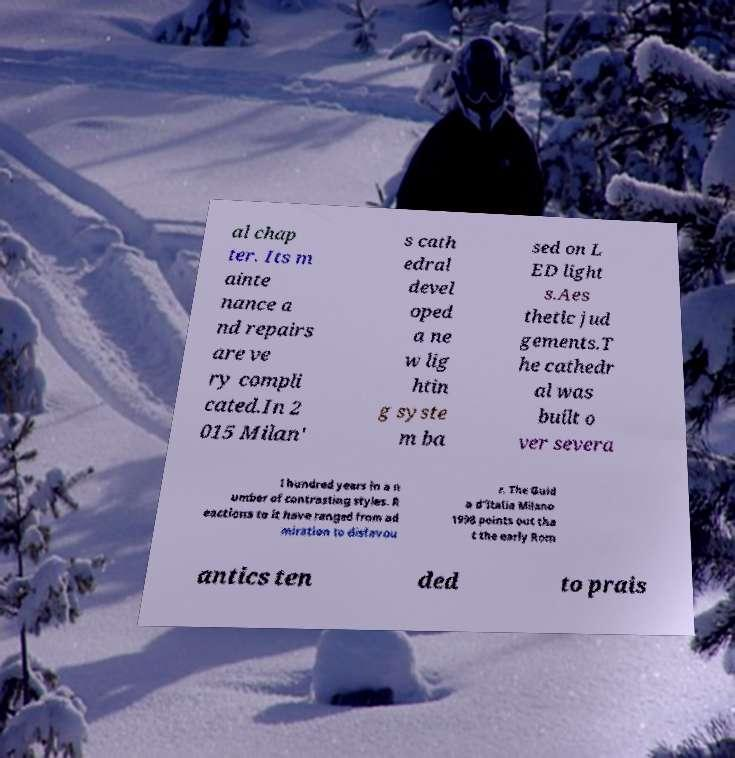Please read and relay the text visible in this image. What does it say? al chap ter. Its m ainte nance a nd repairs are ve ry compli cated.In 2 015 Milan' s cath edral devel oped a ne w lig htin g syste m ba sed on L ED light s.Aes thetic jud gements.T he cathedr al was built o ver severa l hundred years in a n umber of contrasting styles. R eactions to it have ranged from ad miration to disfavou r. The Guid a d’Italia Milano 1998 points out tha t the early Rom antics ten ded to prais 